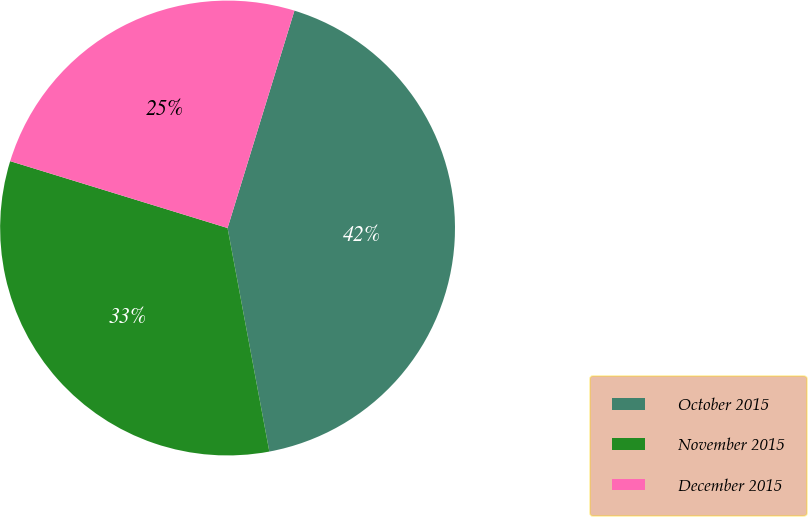<chart> <loc_0><loc_0><loc_500><loc_500><pie_chart><fcel>October 2015<fcel>November 2015<fcel>December 2015<nl><fcel>42.31%<fcel>32.69%<fcel>25.0%<nl></chart> 